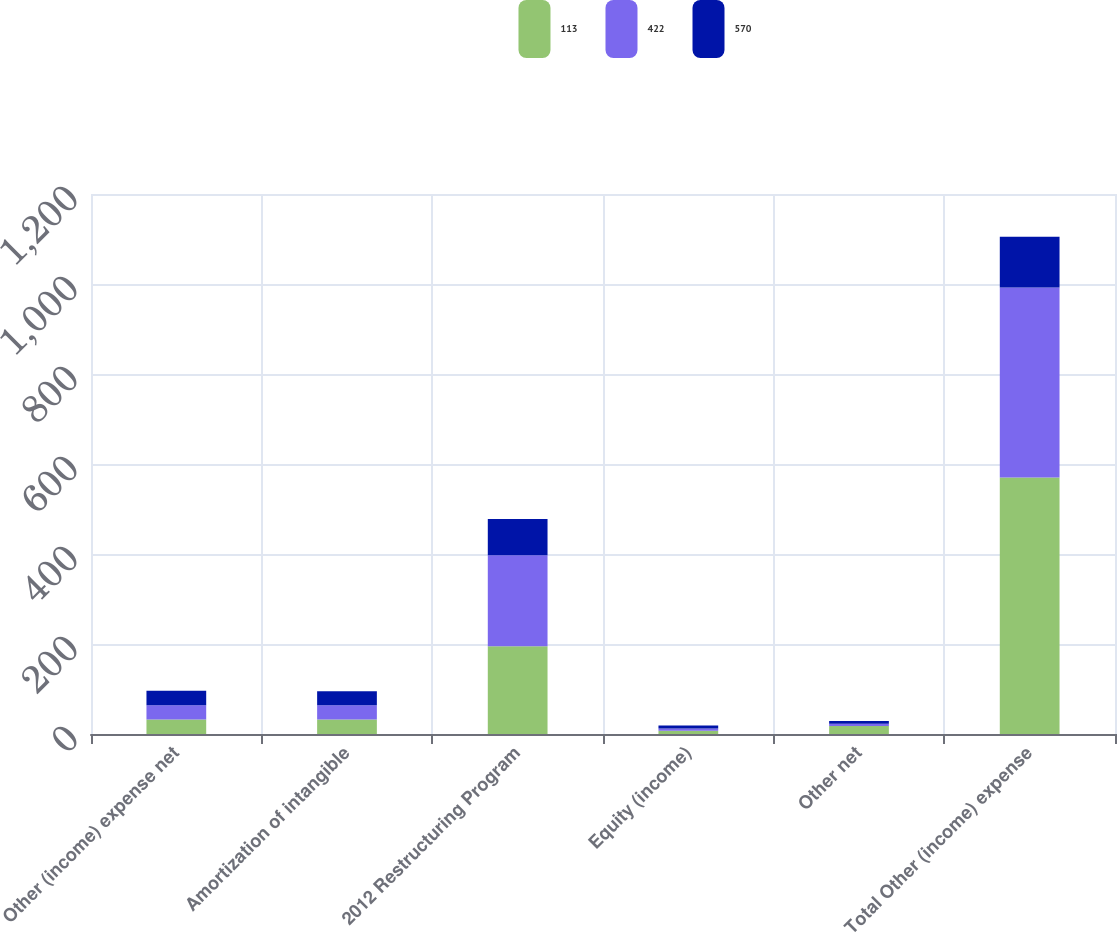<chart> <loc_0><loc_0><loc_500><loc_500><stacked_bar_chart><ecel><fcel>Other (income) expense net<fcel>Amortization of intangible<fcel>2012 Restructuring Program<fcel>Equity (income)<fcel>Other net<fcel>Total Other (income) expense<nl><fcel>113<fcel>32<fcel>32<fcel>195<fcel>7<fcel>18<fcel>570<nl><fcel>422<fcel>32<fcel>32<fcel>202<fcel>5<fcel>5<fcel>422<nl><fcel>570<fcel>32<fcel>31<fcel>81<fcel>7<fcel>6<fcel>113<nl></chart> 